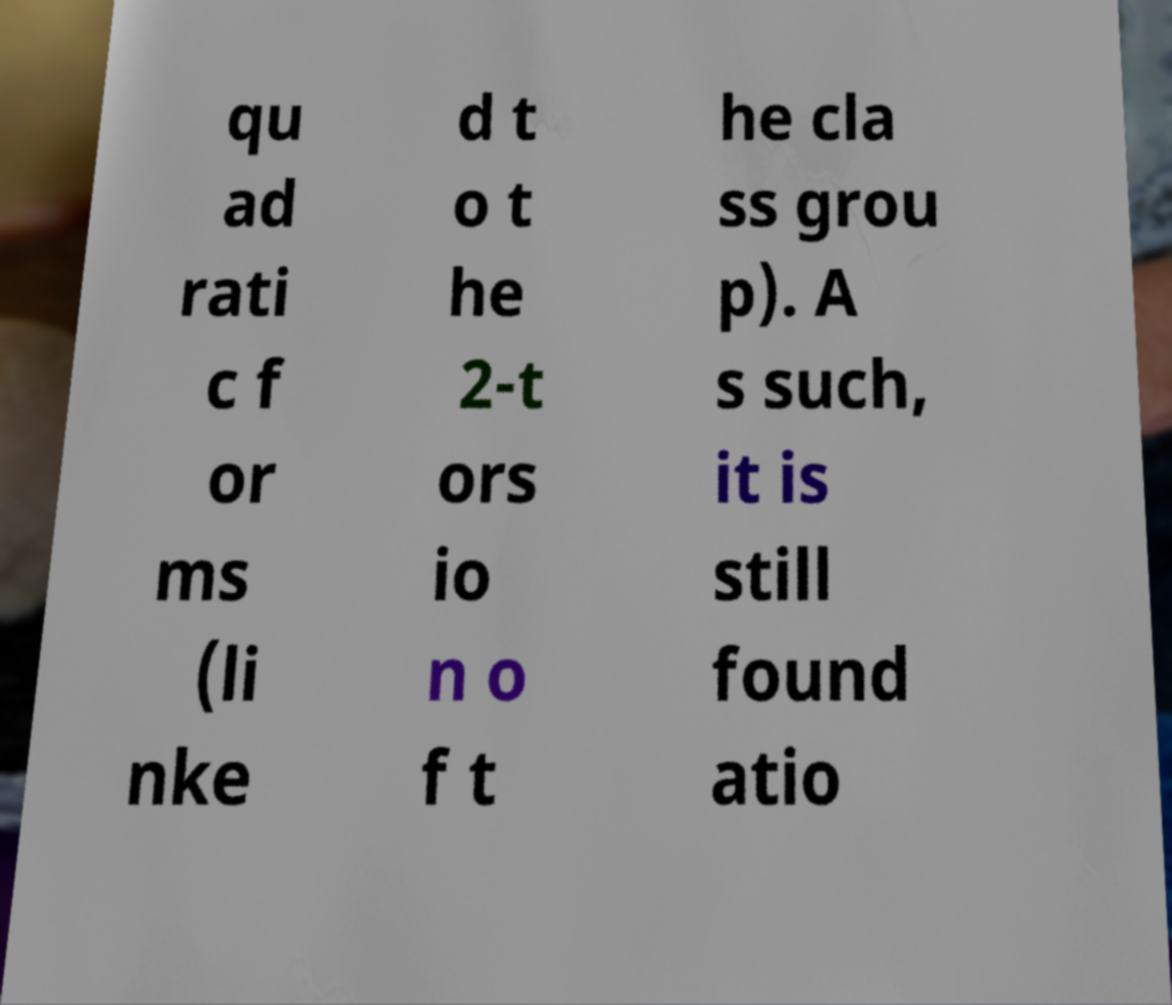For documentation purposes, I need the text within this image transcribed. Could you provide that? qu ad rati c f or ms (li nke d t o t he 2-t ors io n o f t he cla ss grou p). A s such, it is still found atio 